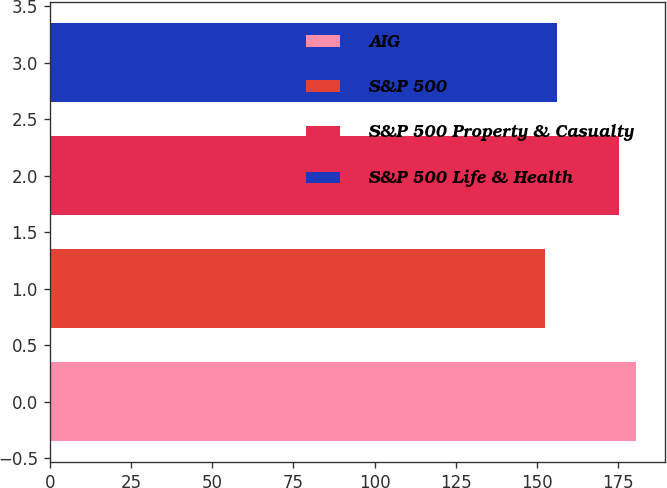Convert chart to OTSL. <chart><loc_0><loc_0><loc_500><loc_500><bar_chart><fcel>AIG<fcel>S&P 500<fcel>S&P 500 Property & Casualty<fcel>S&P 500 Life & Health<nl><fcel>180.37<fcel>152.59<fcel>175.32<fcel>156.14<nl></chart> 